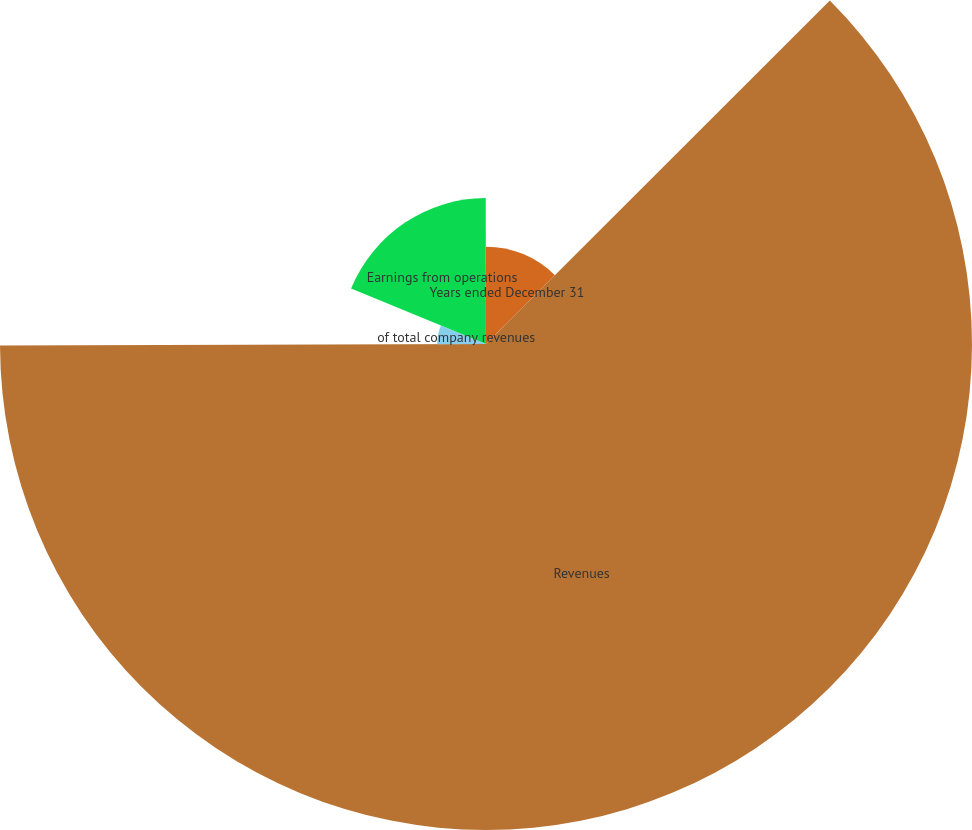Convert chart. <chart><loc_0><loc_0><loc_500><loc_500><pie_chart><fcel>Years ended December 31<fcel>Revenues<fcel>of total company revenues<fcel>Earnings from operations<fcel>Operating margins<nl><fcel>12.51%<fcel>62.45%<fcel>6.27%<fcel>18.75%<fcel>0.03%<nl></chart> 